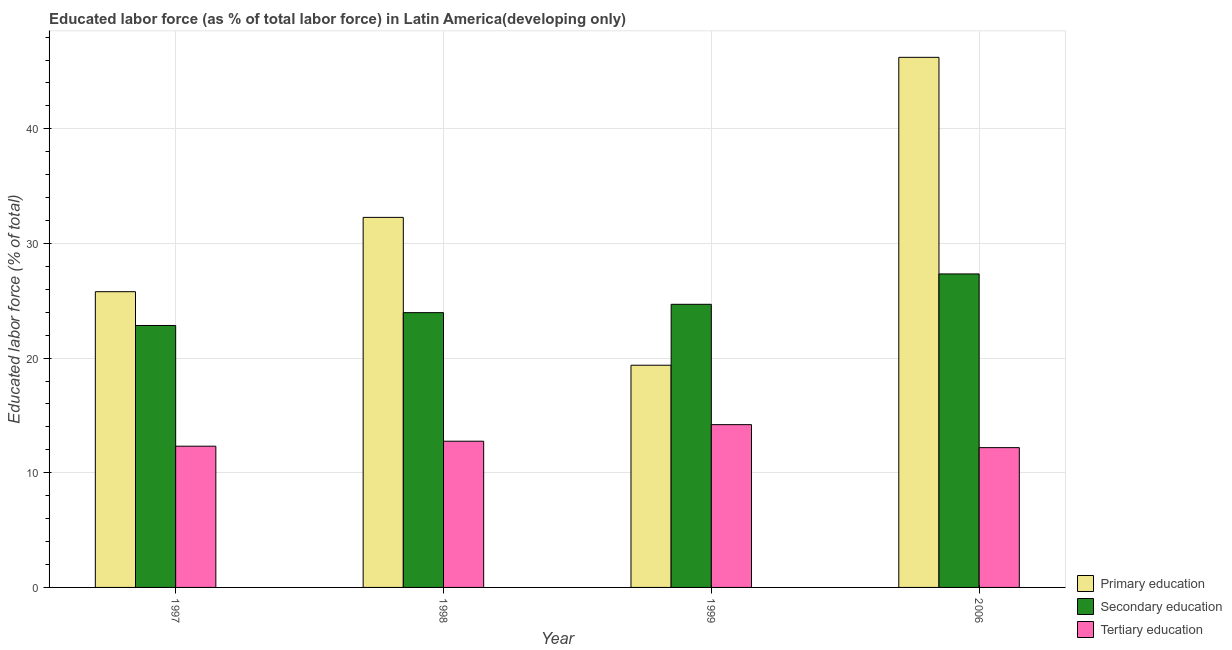How many different coloured bars are there?
Give a very brief answer. 3. Are the number of bars on each tick of the X-axis equal?
Provide a short and direct response. Yes. How many bars are there on the 4th tick from the left?
Your answer should be compact. 3. What is the percentage of labor force who received secondary education in 1998?
Make the answer very short. 23.97. Across all years, what is the maximum percentage of labor force who received primary education?
Keep it short and to the point. 46.24. Across all years, what is the minimum percentage of labor force who received tertiary education?
Provide a short and direct response. 12.19. In which year was the percentage of labor force who received primary education minimum?
Your answer should be compact. 1999. What is the total percentage of labor force who received tertiary education in the graph?
Provide a succinct answer. 51.46. What is the difference between the percentage of labor force who received primary education in 1997 and that in 1998?
Give a very brief answer. -6.48. What is the difference between the percentage of labor force who received tertiary education in 1999 and the percentage of labor force who received primary education in 1998?
Make the answer very short. 1.45. What is the average percentage of labor force who received secondary education per year?
Give a very brief answer. 24.71. In the year 1998, what is the difference between the percentage of labor force who received tertiary education and percentage of labor force who received secondary education?
Offer a terse response. 0. What is the ratio of the percentage of labor force who received secondary education in 1999 to that in 2006?
Ensure brevity in your answer.  0.9. What is the difference between the highest and the second highest percentage of labor force who received secondary education?
Your answer should be very brief. 2.65. What is the difference between the highest and the lowest percentage of labor force who received primary education?
Provide a succinct answer. 26.85. In how many years, is the percentage of labor force who received secondary education greater than the average percentage of labor force who received secondary education taken over all years?
Give a very brief answer. 1. What does the 2nd bar from the left in 2006 represents?
Offer a very short reply. Secondary education. What does the 2nd bar from the right in 1998 represents?
Offer a terse response. Secondary education. How many bars are there?
Provide a short and direct response. 12. Are all the bars in the graph horizontal?
Provide a succinct answer. No. How many years are there in the graph?
Ensure brevity in your answer.  4. What is the difference between two consecutive major ticks on the Y-axis?
Your answer should be compact. 10. Does the graph contain any zero values?
Provide a short and direct response. No. Does the graph contain grids?
Your answer should be compact. Yes. What is the title of the graph?
Provide a short and direct response. Educated labor force (as % of total labor force) in Latin America(developing only). Does "ICT services" appear as one of the legend labels in the graph?
Ensure brevity in your answer.  No. What is the label or title of the X-axis?
Keep it short and to the point. Year. What is the label or title of the Y-axis?
Your answer should be very brief. Educated labor force (% of total). What is the Educated labor force (% of total) of Primary education in 1997?
Provide a short and direct response. 25.79. What is the Educated labor force (% of total) in Secondary education in 1997?
Your answer should be very brief. 22.85. What is the Educated labor force (% of total) in Tertiary education in 1997?
Offer a very short reply. 12.32. What is the Educated labor force (% of total) of Primary education in 1998?
Offer a very short reply. 32.28. What is the Educated labor force (% of total) in Secondary education in 1998?
Offer a terse response. 23.97. What is the Educated labor force (% of total) in Tertiary education in 1998?
Make the answer very short. 12.75. What is the Educated labor force (% of total) of Primary education in 1999?
Ensure brevity in your answer.  19.38. What is the Educated labor force (% of total) of Secondary education in 1999?
Your answer should be compact. 24.69. What is the Educated labor force (% of total) in Tertiary education in 1999?
Keep it short and to the point. 14.2. What is the Educated labor force (% of total) in Primary education in 2006?
Your response must be concise. 46.24. What is the Educated labor force (% of total) of Secondary education in 2006?
Offer a very short reply. 27.34. What is the Educated labor force (% of total) of Tertiary education in 2006?
Provide a succinct answer. 12.19. Across all years, what is the maximum Educated labor force (% of total) in Primary education?
Provide a succinct answer. 46.24. Across all years, what is the maximum Educated labor force (% of total) of Secondary education?
Keep it short and to the point. 27.34. Across all years, what is the maximum Educated labor force (% of total) in Tertiary education?
Provide a succinct answer. 14.2. Across all years, what is the minimum Educated labor force (% of total) of Primary education?
Offer a terse response. 19.38. Across all years, what is the minimum Educated labor force (% of total) of Secondary education?
Offer a very short reply. 22.85. Across all years, what is the minimum Educated labor force (% of total) in Tertiary education?
Offer a very short reply. 12.19. What is the total Educated labor force (% of total) of Primary education in the graph?
Give a very brief answer. 123.69. What is the total Educated labor force (% of total) of Secondary education in the graph?
Your answer should be compact. 98.85. What is the total Educated labor force (% of total) in Tertiary education in the graph?
Offer a terse response. 51.46. What is the difference between the Educated labor force (% of total) of Primary education in 1997 and that in 1998?
Keep it short and to the point. -6.48. What is the difference between the Educated labor force (% of total) in Secondary education in 1997 and that in 1998?
Offer a very short reply. -1.12. What is the difference between the Educated labor force (% of total) of Tertiary education in 1997 and that in 1998?
Your response must be concise. -0.43. What is the difference between the Educated labor force (% of total) of Primary education in 1997 and that in 1999?
Keep it short and to the point. 6.41. What is the difference between the Educated labor force (% of total) in Secondary education in 1997 and that in 1999?
Provide a short and direct response. -1.85. What is the difference between the Educated labor force (% of total) of Tertiary education in 1997 and that in 1999?
Keep it short and to the point. -1.88. What is the difference between the Educated labor force (% of total) of Primary education in 1997 and that in 2006?
Ensure brevity in your answer.  -20.44. What is the difference between the Educated labor force (% of total) of Secondary education in 1997 and that in 2006?
Provide a succinct answer. -4.5. What is the difference between the Educated labor force (% of total) in Tertiary education in 1997 and that in 2006?
Provide a short and direct response. 0.13. What is the difference between the Educated labor force (% of total) of Primary education in 1998 and that in 1999?
Offer a terse response. 12.89. What is the difference between the Educated labor force (% of total) of Secondary education in 1998 and that in 1999?
Provide a succinct answer. -0.73. What is the difference between the Educated labor force (% of total) in Tertiary education in 1998 and that in 1999?
Provide a short and direct response. -1.45. What is the difference between the Educated labor force (% of total) of Primary education in 1998 and that in 2006?
Your answer should be very brief. -13.96. What is the difference between the Educated labor force (% of total) of Secondary education in 1998 and that in 2006?
Make the answer very short. -3.38. What is the difference between the Educated labor force (% of total) in Tertiary education in 1998 and that in 2006?
Provide a succinct answer. 0.56. What is the difference between the Educated labor force (% of total) of Primary education in 1999 and that in 2006?
Make the answer very short. -26.85. What is the difference between the Educated labor force (% of total) in Secondary education in 1999 and that in 2006?
Your answer should be compact. -2.65. What is the difference between the Educated labor force (% of total) of Tertiary education in 1999 and that in 2006?
Keep it short and to the point. 2.01. What is the difference between the Educated labor force (% of total) of Primary education in 1997 and the Educated labor force (% of total) of Secondary education in 1998?
Make the answer very short. 1.83. What is the difference between the Educated labor force (% of total) in Primary education in 1997 and the Educated labor force (% of total) in Tertiary education in 1998?
Offer a very short reply. 13.04. What is the difference between the Educated labor force (% of total) in Secondary education in 1997 and the Educated labor force (% of total) in Tertiary education in 1998?
Ensure brevity in your answer.  10.09. What is the difference between the Educated labor force (% of total) in Primary education in 1997 and the Educated labor force (% of total) in Secondary education in 1999?
Give a very brief answer. 1.1. What is the difference between the Educated labor force (% of total) of Primary education in 1997 and the Educated labor force (% of total) of Tertiary education in 1999?
Offer a very short reply. 11.6. What is the difference between the Educated labor force (% of total) of Secondary education in 1997 and the Educated labor force (% of total) of Tertiary education in 1999?
Provide a succinct answer. 8.65. What is the difference between the Educated labor force (% of total) in Primary education in 1997 and the Educated labor force (% of total) in Secondary education in 2006?
Your answer should be very brief. -1.55. What is the difference between the Educated labor force (% of total) of Primary education in 1997 and the Educated labor force (% of total) of Tertiary education in 2006?
Make the answer very short. 13.6. What is the difference between the Educated labor force (% of total) of Secondary education in 1997 and the Educated labor force (% of total) of Tertiary education in 2006?
Ensure brevity in your answer.  10.66. What is the difference between the Educated labor force (% of total) in Primary education in 1998 and the Educated labor force (% of total) in Secondary education in 1999?
Provide a short and direct response. 7.58. What is the difference between the Educated labor force (% of total) of Primary education in 1998 and the Educated labor force (% of total) of Tertiary education in 1999?
Provide a succinct answer. 18.08. What is the difference between the Educated labor force (% of total) of Secondary education in 1998 and the Educated labor force (% of total) of Tertiary education in 1999?
Provide a short and direct response. 9.77. What is the difference between the Educated labor force (% of total) of Primary education in 1998 and the Educated labor force (% of total) of Secondary education in 2006?
Your answer should be compact. 4.93. What is the difference between the Educated labor force (% of total) in Primary education in 1998 and the Educated labor force (% of total) in Tertiary education in 2006?
Keep it short and to the point. 20.08. What is the difference between the Educated labor force (% of total) in Secondary education in 1998 and the Educated labor force (% of total) in Tertiary education in 2006?
Provide a succinct answer. 11.77. What is the difference between the Educated labor force (% of total) of Primary education in 1999 and the Educated labor force (% of total) of Secondary education in 2006?
Keep it short and to the point. -7.96. What is the difference between the Educated labor force (% of total) in Primary education in 1999 and the Educated labor force (% of total) in Tertiary education in 2006?
Give a very brief answer. 7.19. What is the difference between the Educated labor force (% of total) of Secondary education in 1999 and the Educated labor force (% of total) of Tertiary education in 2006?
Offer a very short reply. 12.5. What is the average Educated labor force (% of total) of Primary education per year?
Your answer should be very brief. 30.92. What is the average Educated labor force (% of total) of Secondary education per year?
Your answer should be very brief. 24.71. What is the average Educated labor force (% of total) in Tertiary education per year?
Give a very brief answer. 12.87. In the year 1997, what is the difference between the Educated labor force (% of total) in Primary education and Educated labor force (% of total) in Secondary education?
Provide a short and direct response. 2.95. In the year 1997, what is the difference between the Educated labor force (% of total) in Primary education and Educated labor force (% of total) in Tertiary education?
Offer a terse response. 13.47. In the year 1997, what is the difference between the Educated labor force (% of total) in Secondary education and Educated labor force (% of total) in Tertiary education?
Your answer should be compact. 10.53. In the year 1998, what is the difference between the Educated labor force (% of total) of Primary education and Educated labor force (% of total) of Secondary education?
Make the answer very short. 8.31. In the year 1998, what is the difference between the Educated labor force (% of total) of Primary education and Educated labor force (% of total) of Tertiary education?
Provide a succinct answer. 19.52. In the year 1998, what is the difference between the Educated labor force (% of total) of Secondary education and Educated labor force (% of total) of Tertiary education?
Your response must be concise. 11.21. In the year 1999, what is the difference between the Educated labor force (% of total) of Primary education and Educated labor force (% of total) of Secondary education?
Your answer should be compact. -5.31. In the year 1999, what is the difference between the Educated labor force (% of total) of Primary education and Educated labor force (% of total) of Tertiary education?
Offer a terse response. 5.18. In the year 1999, what is the difference between the Educated labor force (% of total) of Secondary education and Educated labor force (% of total) of Tertiary education?
Keep it short and to the point. 10.5. In the year 2006, what is the difference between the Educated labor force (% of total) in Primary education and Educated labor force (% of total) in Secondary education?
Your answer should be compact. 18.89. In the year 2006, what is the difference between the Educated labor force (% of total) of Primary education and Educated labor force (% of total) of Tertiary education?
Provide a short and direct response. 34.04. In the year 2006, what is the difference between the Educated labor force (% of total) in Secondary education and Educated labor force (% of total) in Tertiary education?
Offer a very short reply. 15.15. What is the ratio of the Educated labor force (% of total) in Primary education in 1997 to that in 1998?
Provide a short and direct response. 0.8. What is the ratio of the Educated labor force (% of total) of Secondary education in 1997 to that in 1998?
Give a very brief answer. 0.95. What is the ratio of the Educated labor force (% of total) of Primary education in 1997 to that in 1999?
Your answer should be very brief. 1.33. What is the ratio of the Educated labor force (% of total) in Secondary education in 1997 to that in 1999?
Your answer should be compact. 0.93. What is the ratio of the Educated labor force (% of total) in Tertiary education in 1997 to that in 1999?
Make the answer very short. 0.87. What is the ratio of the Educated labor force (% of total) in Primary education in 1997 to that in 2006?
Offer a very short reply. 0.56. What is the ratio of the Educated labor force (% of total) in Secondary education in 1997 to that in 2006?
Make the answer very short. 0.84. What is the ratio of the Educated labor force (% of total) in Tertiary education in 1997 to that in 2006?
Offer a terse response. 1.01. What is the ratio of the Educated labor force (% of total) in Primary education in 1998 to that in 1999?
Give a very brief answer. 1.67. What is the ratio of the Educated labor force (% of total) of Secondary education in 1998 to that in 1999?
Your answer should be compact. 0.97. What is the ratio of the Educated labor force (% of total) of Tertiary education in 1998 to that in 1999?
Your response must be concise. 0.9. What is the ratio of the Educated labor force (% of total) of Primary education in 1998 to that in 2006?
Provide a short and direct response. 0.7. What is the ratio of the Educated labor force (% of total) of Secondary education in 1998 to that in 2006?
Provide a short and direct response. 0.88. What is the ratio of the Educated labor force (% of total) in Tertiary education in 1998 to that in 2006?
Provide a succinct answer. 1.05. What is the ratio of the Educated labor force (% of total) of Primary education in 1999 to that in 2006?
Your answer should be very brief. 0.42. What is the ratio of the Educated labor force (% of total) in Secondary education in 1999 to that in 2006?
Provide a succinct answer. 0.9. What is the ratio of the Educated labor force (% of total) of Tertiary education in 1999 to that in 2006?
Your response must be concise. 1.16. What is the difference between the highest and the second highest Educated labor force (% of total) of Primary education?
Offer a terse response. 13.96. What is the difference between the highest and the second highest Educated labor force (% of total) in Secondary education?
Provide a short and direct response. 2.65. What is the difference between the highest and the second highest Educated labor force (% of total) of Tertiary education?
Offer a very short reply. 1.45. What is the difference between the highest and the lowest Educated labor force (% of total) in Primary education?
Provide a short and direct response. 26.85. What is the difference between the highest and the lowest Educated labor force (% of total) of Secondary education?
Give a very brief answer. 4.5. What is the difference between the highest and the lowest Educated labor force (% of total) of Tertiary education?
Ensure brevity in your answer.  2.01. 